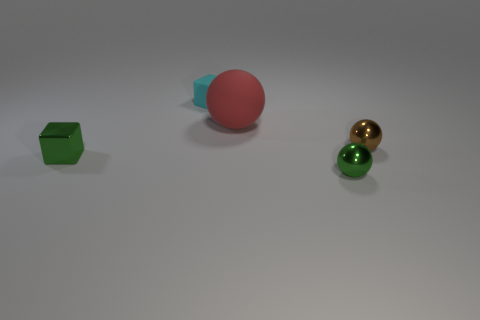Add 3 metallic blocks. How many objects exist? 8 Subtract all spheres. How many objects are left? 2 Subtract all green cubes. Subtract all tiny green objects. How many objects are left? 2 Add 2 small balls. How many small balls are left? 4 Add 2 spheres. How many spheres exist? 5 Subtract 0 cyan balls. How many objects are left? 5 